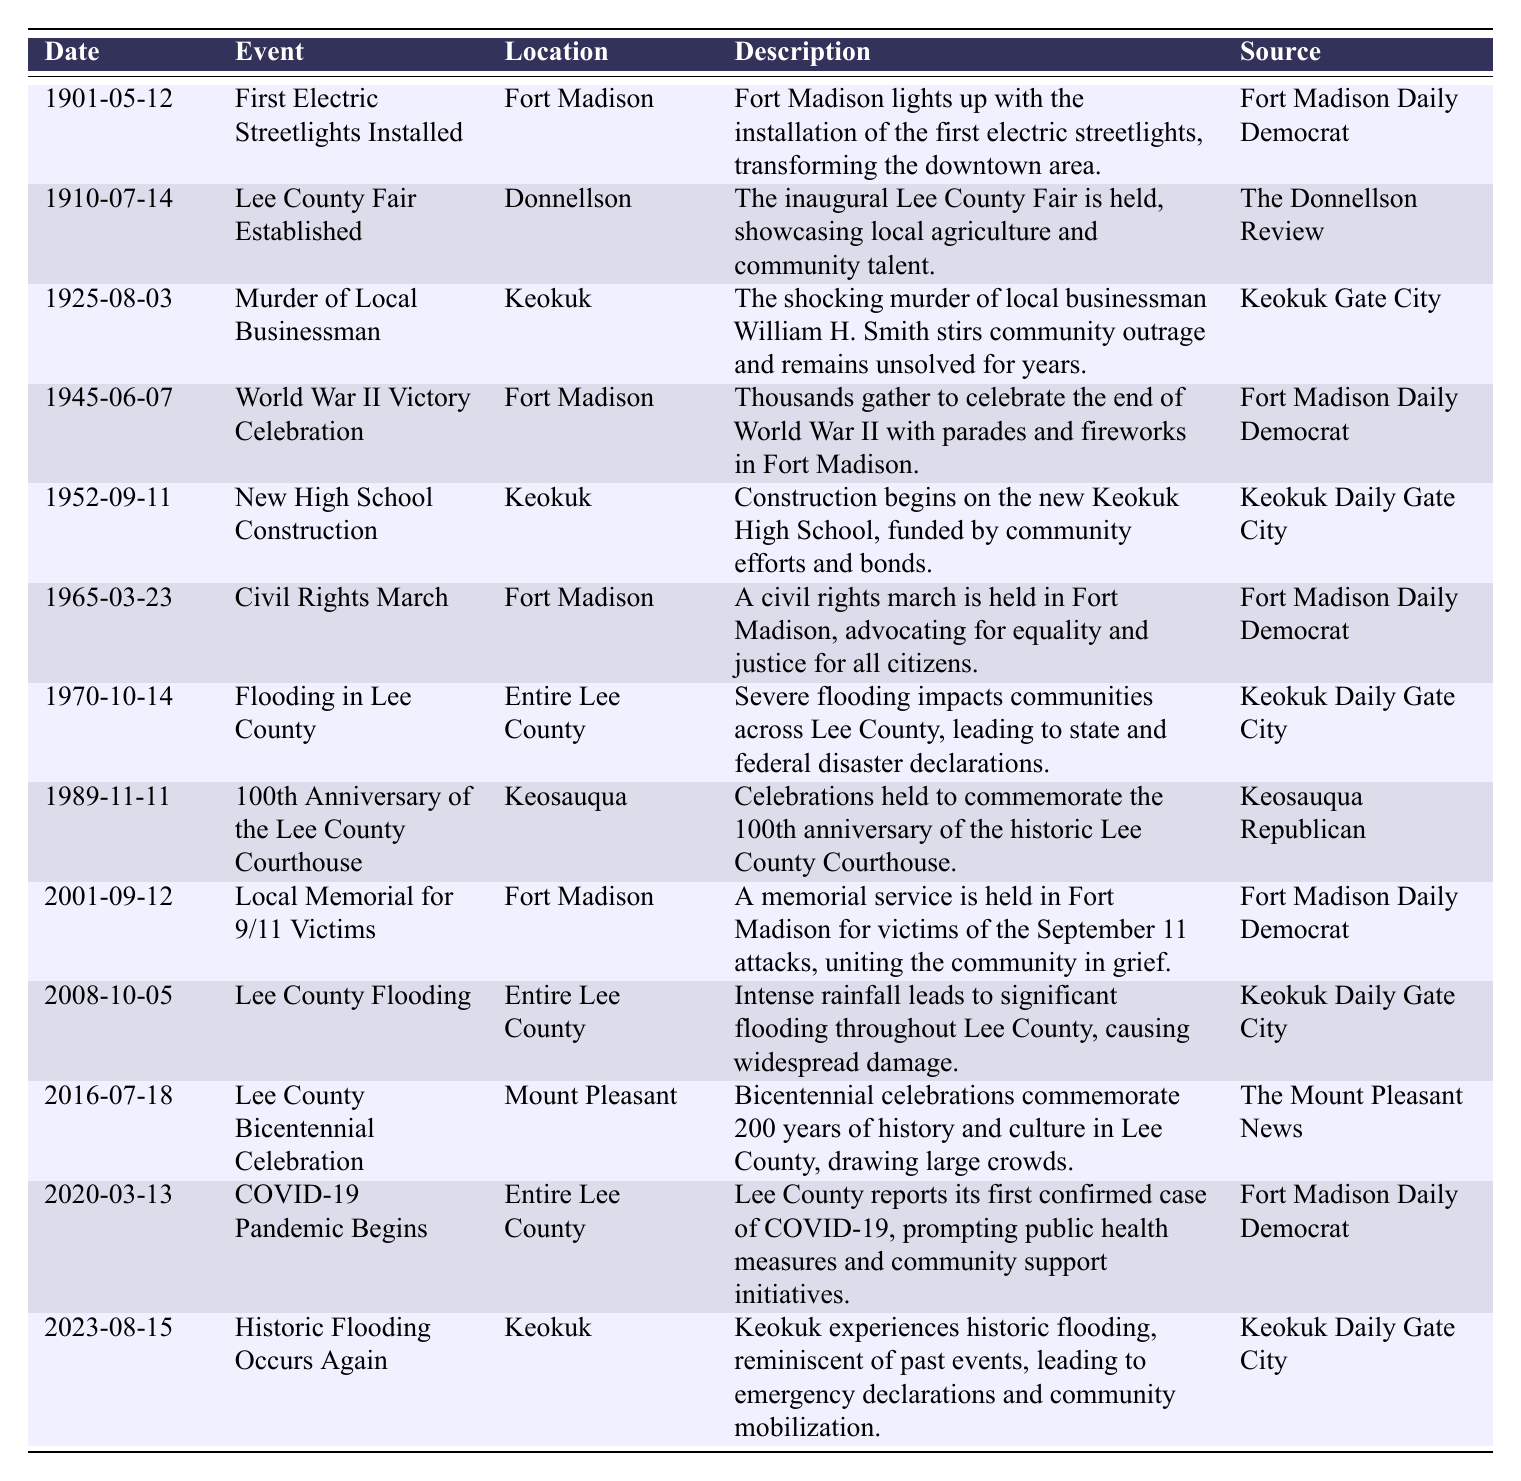What significant event occurred in Lee County on May 12, 1901? The table shows that on May 12, 1901, the first electric streetlights were installed in Fort Madison, transforming the downtown area.
Answer: First Electric Streetlights Installed Which event was celebrated in Mount Pleasant in 2016? According to the table, in 2016, the Lee County Bicentennial Celebration commemorated 200 years of history and culture in the area.
Answer: Lee County Bicentennial Celebration How many events related to flooding are listed in the table? The table indicates there are three events related to flooding: on October 14, 1970, October 5, 2008, and August 15, 2023. Therefore, the count is three.
Answer: 3 Was the Lee County Fair established before or after World War II? The table states that the Lee County Fair was established on July 14, 1910, which is before the World War II Victory Celebration on June 7, 1945.
Answer: Before What event took place in Keokuk on August 3, 1925? The table reveals that on August 3, 1925, the shocking murder of local businessman William H. Smith occurred, stirring community outrage.
Answer: Murder of Local Businessman How many years passed between the establishment of the Lee County Fair and the 100th anniversary of the Lee County Courthouse? The Lee County Fair was established in 1910 and the courthouse's 100th anniversary was in 1989. The difference in years is 1989 - 1910 = 79.
Answer: 79 Which newspaper reported on the historic flooding that occurred on August 15, 2023? The table specifies that the Keokuk Daily Gate City reported on the historic flooding that occurred in Keokuk on August 15, 2023.
Answer: Keokuk Daily Gate City Did any event occur in Donnellson according to the table? Yes, the table indicates that the Lee County Fair was established in Donnellson on July 14, 1910.
Answer: Yes What was the earliest event documented in the table? The earliest event is the installation of electric streetlights in Fort Madison on May 12, 1901.
Answer: First Electric Streetlights Installed How many events are documented in Fort Madison throughout the table? The table shows that there are four events that occurred in Fort Madison: the first electric streetlights, the World War II victory celebration, the civil rights march, and the memorial for 9/11 victims. Adding them up gives us four events.
Answer: 4 